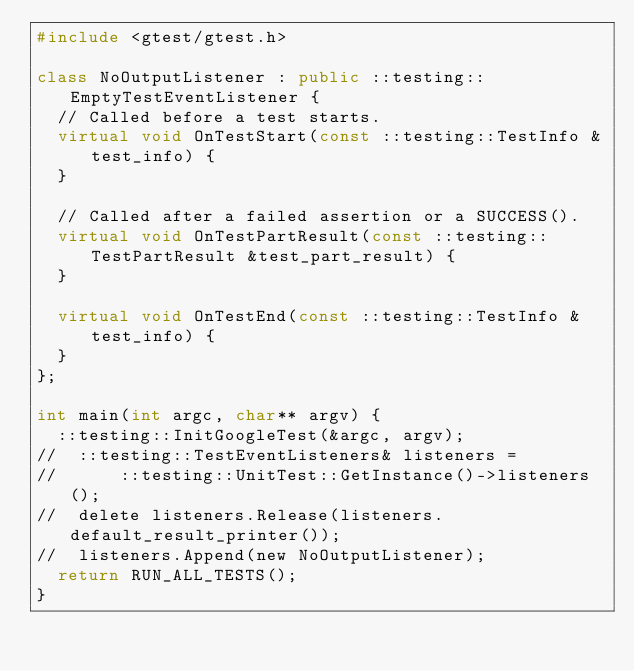Convert code to text. <code><loc_0><loc_0><loc_500><loc_500><_C++_>#include <gtest/gtest.h>

class NoOutputListener : public ::testing::EmptyTestEventListener {
  // Called before a test starts.
  virtual void OnTestStart(const ::testing::TestInfo &test_info) {
  }

  // Called after a failed assertion or a SUCCESS().
  virtual void OnTestPartResult(const ::testing::TestPartResult &test_part_result) {
  }

  virtual void OnTestEnd(const ::testing::TestInfo &test_info) {
  }
};

int main(int argc, char** argv) {
  ::testing::InitGoogleTest(&argc, argv);
//  ::testing::TestEventListeners& listeners =
//      ::testing::UnitTest::GetInstance()->listeners();
//  delete listeners.Release(listeners.default_result_printer());
//  listeners.Append(new NoOutputListener);
  return RUN_ALL_TESTS();
}
</code> 